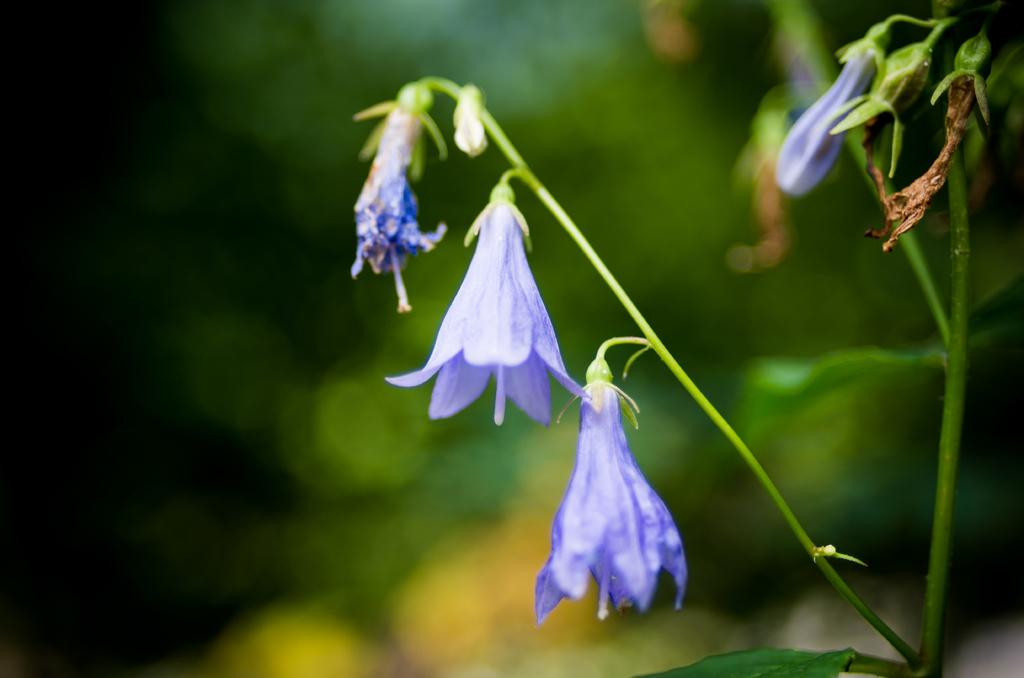What type of plant is visible in the image? There is a flowering plant in the image. Where is the flowering plant located in the image? The flowering plant is on the right side of the image. What type of car is parked next to the flowering plant in the image? There is no car present in the image; it only features a flowering plant on the right side. 